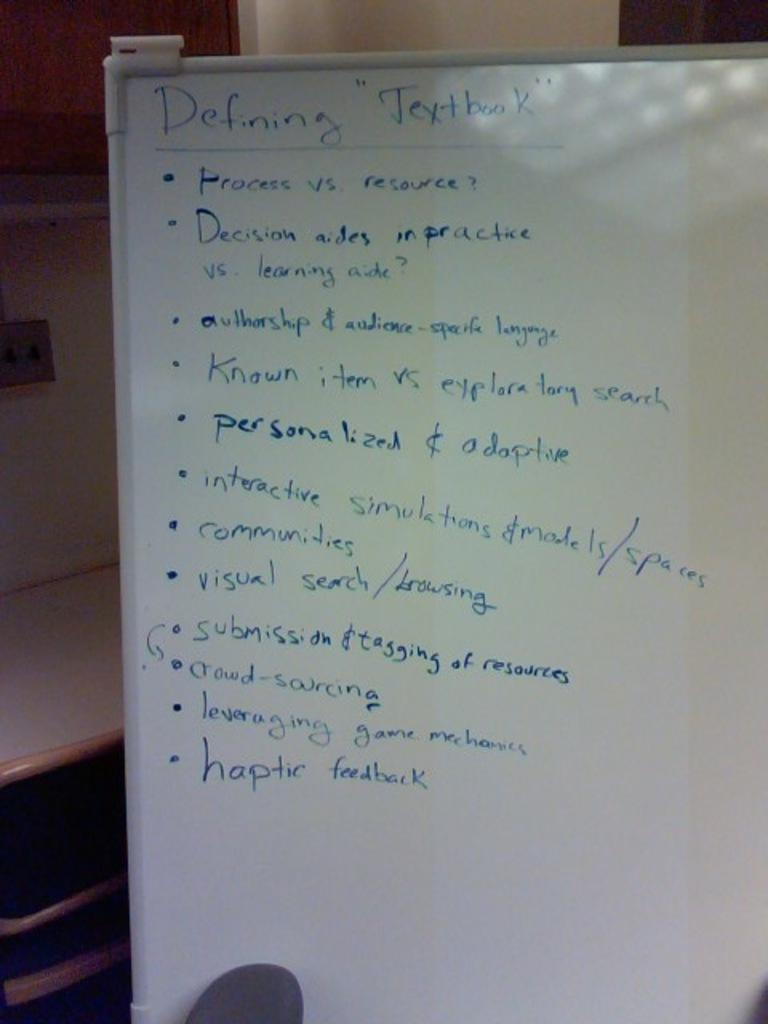<image>
Describe the image concisely. A whiteboard has blue writing on it that says Defining "Textbook". 